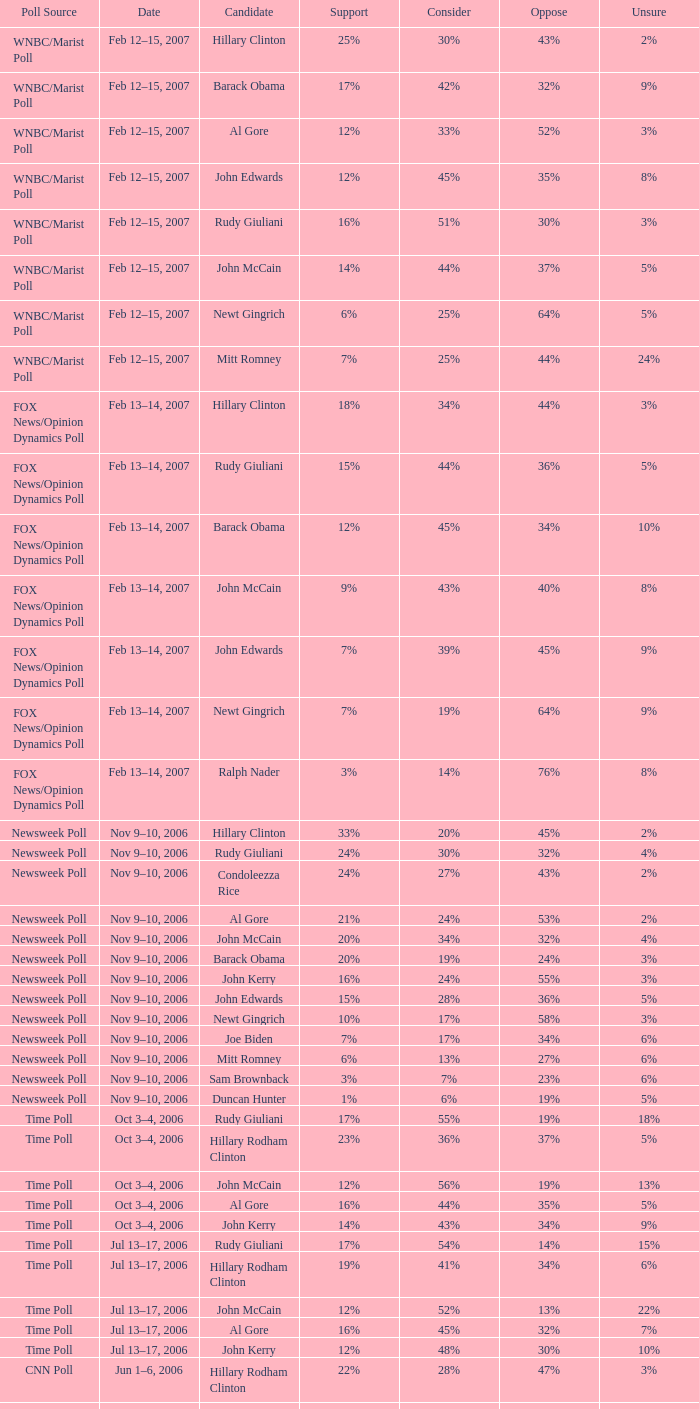In the wnbc/marist poll where 8% of people were undecided, what was the percentage of those who opposed the candidate? 35%. 